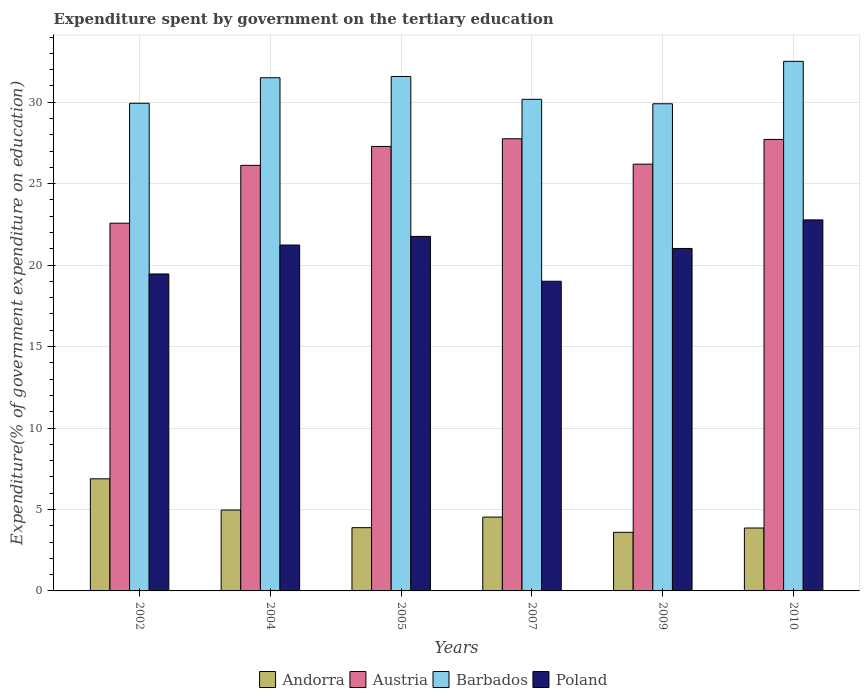How many groups of bars are there?
Your response must be concise. 6. Are the number of bars per tick equal to the number of legend labels?
Ensure brevity in your answer.  Yes. Are the number of bars on each tick of the X-axis equal?
Your response must be concise. Yes. How many bars are there on the 4th tick from the left?
Keep it short and to the point. 4. How many bars are there on the 1st tick from the right?
Offer a terse response. 4. What is the label of the 1st group of bars from the left?
Provide a short and direct response. 2002. What is the expenditure spent by government on the tertiary education in Barbados in 2009?
Give a very brief answer. 29.9. Across all years, what is the maximum expenditure spent by government on the tertiary education in Barbados?
Provide a short and direct response. 32.51. Across all years, what is the minimum expenditure spent by government on the tertiary education in Austria?
Your answer should be very brief. 22.57. What is the total expenditure spent by government on the tertiary education in Austria in the graph?
Your answer should be compact. 157.64. What is the difference between the expenditure spent by government on the tertiary education in Barbados in 2002 and that in 2007?
Ensure brevity in your answer.  -0.24. What is the difference between the expenditure spent by government on the tertiary education in Poland in 2007 and the expenditure spent by government on the tertiary education in Barbados in 2004?
Ensure brevity in your answer.  -12.49. What is the average expenditure spent by government on the tertiary education in Barbados per year?
Provide a succinct answer. 30.93. In the year 2009, what is the difference between the expenditure spent by government on the tertiary education in Andorra and expenditure spent by government on the tertiary education in Barbados?
Offer a very short reply. -26.3. In how many years, is the expenditure spent by government on the tertiary education in Austria greater than 13 %?
Your answer should be compact. 6. What is the ratio of the expenditure spent by government on the tertiary education in Barbados in 2007 to that in 2009?
Offer a very short reply. 1.01. Is the expenditure spent by government on the tertiary education in Barbados in 2002 less than that in 2009?
Ensure brevity in your answer.  No. What is the difference between the highest and the second highest expenditure spent by government on the tertiary education in Austria?
Keep it short and to the point. 0.04. What is the difference between the highest and the lowest expenditure spent by government on the tertiary education in Poland?
Your response must be concise. 3.77. In how many years, is the expenditure spent by government on the tertiary education in Andorra greater than the average expenditure spent by government on the tertiary education in Andorra taken over all years?
Provide a short and direct response. 2. Is the sum of the expenditure spent by government on the tertiary education in Andorra in 2007 and 2010 greater than the maximum expenditure spent by government on the tertiary education in Austria across all years?
Give a very brief answer. No. Is it the case that in every year, the sum of the expenditure spent by government on the tertiary education in Barbados and expenditure spent by government on the tertiary education in Andorra is greater than the sum of expenditure spent by government on the tertiary education in Austria and expenditure spent by government on the tertiary education in Poland?
Your answer should be very brief. No. What does the 4th bar from the right in 2010 represents?
Your answer should be compact. Andorra. Is it the case that in every year, the sum of the expenditure spent by government on the tertiary education in Austria and expenditure spent by government on the tertiary education in Poland is greater than the expenditure spent by government on the tertiary education in Andorra?
Offer a terse response. Yes. How many bars are there?
Provide a succinct answer. 24. Are all the bars in the graph horizontal?
Provide a succinct answer. No. What is the difference between two consecutive major ticks on the Y-axis?
Keep it short and to the point. 5. Are the values on the major ticks of Y-axis written in scientific E-notation?
Provide a short and direct response. No. Does the graph contain any zero values?
Ensure brevity in your answer.  No. Does the graph contain grids?
Your answer should be very brief. Yes. Where does the legend appear in the graph?
Ensure brevity in your answer.  Bottom center. How many legend labels are there?
Provide a succinct answer. 4. What is the title of the graph?
Offer a terse response. Expenditure spent by government on the tertiary education. Does "Mongolia" appear as one of the legend labels in the graph?
Your answer should be compact. No. What is the label or title of the Y-axis?
Offer a very short reply. Expenditure(% of government expenditure on education). What is the Expenditure(% of government expenditure on education) in Andorra in 2002?
Ensure brevity in your answer.  6.88. What is the Expenditure(% of government expenditure on education) of Austria in 2002?
Keep it short and to the point. 22.57. What is the Expenditure(% of government expenditure on education) of Barbados in 2002?
Make the answer very short. 29.93. What is the Expenditure(% of government expenditure on education) in Poland in 2002?
Your answer should be very brief. 19.45. What is the Expenditure(% of government expenditure on education) of Andorra in 2004?
Provide a short and direct response. 4.96. What is the Expenditure(% of government expenditure on education) in Austria in 2004?
Keep it short and to the point. 26.12. What is the Expenditure(% of government expenditure on education) in Barbados in 2004?
Offer a terse response. 31.5. What is the Expenditure(% of government expenditure on education) in Poland in 2004?
Your answer should be compact. 21.23. What is the Expenditure(% of government expenditure on education) in Andorra in 2005?
Your response must be concise. 3.88. What is the Expenditure(% of government expenditure on education) of Austria in 2005?
Your response must be concise. 27.28. What is the Expenditure(% of government expenditure on education) of Barbados in 2005?
Your answer should be compact. 31.58. What is the Expenditure(% of government expenditure on education) of Poland in 2005?
Offer a very short reply. 21.76. What is the Expenditure(% of government expenditure on education) of Andorra in 2007?
Your answer should be compact. 4.53. What is the Expenditure(% of government expenditure on education) of Austria in 2007?
Your response must be concise. 27.75. What is the Expenditure(% of government expenditure on education) in Barbados in 2007?
Your answer should be very brief. 30.18. What is the Expenditure(% of government expenditure on education) in Poland in 2007?
Provide a short and direct response. 19.01. What is the Expenditure(% of government expenditure on education) of Andorra in 2009?
Your answer should be very brief. 3.6. What is the Expenditure(% of government expenditure on education) of Austria in 2009?
Your response must be concise. 26.2. What is the Expenditure(% of government expenditure on education) in Barbados in 2009?
Ensure brevity in your answer.  29.9. What is the Expenditure(% of government expenditure on education) of Poland in 2009?
Your answer should be compact. 21.02. What is the Expenditure(% of government expenditure on education) of Andorra in 2010?
Your response must be concise. 3.86. What is the Expenditure(% of government expenditure on education) of Austria in 2010?
Offer a terse response. 27.71. What is the Expenditure(% of government expenditure on education) in Barbados in 2010?
Offer a very short reply. 32.51. What is the Expenditure(% of government expenditure on education) of Poland in 2010?
Give a very brief answer. 22.77. Across all years, what is the maximum Expenditure(% of government expenditure on education) of Andorra?
Give a very brief answer. 6.88. Across all years, what is the maximum Expenditure(% of government expenditure on education) of Austria?
Your response must be concise. 27.75. Across all years, what is the maximum Expenditure(% of government expenditure on education) in Barbados?
Ensure brevity in your answer.  32.51. Across all years, what is the maximum Expenditure(% of government expenditure on education) of Poland?
Ensure brevity in your answer.  22.77. Across all years, what is the minimum Expenditure(% of government expenditure on education) in Andorra?
Your answer should be very brief. 3.6. Across all years, what is the minimum Expenditure(% of government expenditure on education) in Austria?
Your answer should be very brief. 22.57. Across all years, what is the minimum Expenditure(% of government expenditure on education) in Barbados?
Ensure brevity in your answer.  29.9. Across all years, what is the minimum Expenditure(% of government expenditure on education) in Poland?
Keep it short and to the point. 19.01. What is the total Expenditure(% of government expenditure on education) of Andorra in the graph?
Your answer should be compact. 27.72. What is the total Expenditure(% of government expenditure on education) of Austria in the graph?
Give a very brief answer. 157.64. What is the total Expenditure(% of government expenditure on education) in Barbados in the graph?
Make the answer very short. 185.6. What is the total Expenditure(% of government expenditure on education) of Poland in the graph?
Your answer should be very brief. 125.25. What is the difference between the Expenditure(% of government expenditure on education) of Andorra in 2002 and that in 2004?
Your response must be concise. 1.92. What is the difference between the Expenditure(% of government expenditure on education) of Austria in 2002 and that in 2004?
Make the answer very short. -3.55. What is the difference between the Expenditure(% of government expenditure on education) in Barbados in 2002 and that in 2004?
Your response must be concise. -1.57. What is the difference between the Expenditure(% of government expenditure on education) of Poland in 2002 and that in 2004?
Offer a very short reply. -1.78. What is the difference between the Expenditure(% of government expenditure on education) of Andorra in 2002 and that in 2005?
Make the answer very short. 3. What is the difference between the Expenditure(% of government expenditure on education) of Austria in 2002 and that in 2005?
Provide a short and direct response. -4.71. What is the difference between the Expenditure(% of government expenditure on education) of Barbados in 2002 and that in 2005?
Offer a very short reply. -1.65. What is the difference between the Expenditure(% of government expenditure on education) in Poland in 2002 and that in 2005?
Offer a terse response. -2.31. What is the difference between the Expenditure(% of government expenditure on education) of Andorra in 2002 and that in 2007?
Your answer should be compact. 2.35. What is the difference between the Expenditure(% of government expenditure on education) in Austria in 2002 and that in 2007?
Ensure brevity in your answer.  -5.18. What is the difference between the Expenditure(% of government expenditure on education) of Barbados in 2002 and that in 2007?
Provide a short and direct response. -0.24. What is the difference between the Expenditure(% of government expenditure on education) of Poland in 2002 and that in 2007?
Offer a terse response. 0.45. What is the difference between the Expenditure(% of government expenditure on education) in Andorra in 2002 and that in 2009?
Offer a very short reply. 3.28. What is the difference between the Expenditure(% of government expenditure on education) in Austria in 2002 and that in 2009?
Make the answer very short. -3.62. What is the difference between the Expenditure(% of government expenditure on education) in Barbados in 2002 and that in 2009?
Provide a succinct answer. 0.03. What is the difference between the Expenditure(% of government expenditure on education) in Poland in 2002 and that in 2009?
Your answer should be very brief. -1.57. What is the difference between the Expenditure(% of government expenditure on education) in Andorra in 2002 and that in 2010?
Your answer should be compact. 3.02. What is the difference between the Expenditure(% of government expenditure on education) in Austria in 2002 and that in 2010?
Provide a short and direct response. -5.14. What is the difference between the Expenditure(% of government expenditure on education) in Barbados in 2002 and that in 2010?
Ensure brevity in your answer.  -2.57. What is the difference between the Expenditure(% of government expenditure on education) in Poland in 2002 and that in 2010?
Ensure brevity in your answer.  -3.32. What is the difference between the Expenditure(% of government expenditure on education) of Andorra in 2004 and that in 2005?
Provide a short and direct response. 1.08. What is the difference between the Expenditure(% of government expenditure on education) of Austria in 2004 and that in 2005?
Your answer should be very brief. -1.16. What is the difference between the Expenditure(% of government expenditure on education) in Barbados in 2004 and that in 2005?
Make the answer very short. -0.08. What is the difference between the Expenditure(% of government expenditure on education) in Poland in 2004 and that in 2005?
Ensure brevity in your answer.  -0.53. What is the difference between the Expenditure(% of government expenditure on education) of Andorra in 2004 and that in 2007?
Your response must be concise. 0.43. What is the difference between the Expenditure(% of government expenditure on education) of Austria in 2004 and that in 2007?
Give a very brief answer. -1.63. What is the difference between the Expenditure(% of government expenditure on education) of Barbados in 2004 and that in 2007?
Ensure brevity in your answer.  1.32. What is the difference between the Expenditure(% of government expenditure on education) of Poland in 2004 and that in 2007?
Your response must be concise. 2.22. What is the difference between the Expenditure(% of government expenditure on education) of Andorra in 2004 and that in 2009?
Make the answer very short. 1.37. What is the difference between the Expenditure(% of government expenditure on education) of Austria in 2004 and that in 2009?
Provide a succinct answer. -0.07. What is the difference between the Expenditure(% of government expenditure on education) in Barbados in 2004 and that in 2009?
Keep it short and to the point. 1.6. What is the difference between the Expenditure(% of government expenditure on education) of Poland in 2004 and that in 2009?
Your response must be concise. 0.21. What is the difference between the Expenditure(% of government expenditure on education) in Andorra in 2004 and that in 2010?
Make the answer very short. 1.1. What is the difference between the Expenditure(% of government expenditure on education) of Austria in 2004 and that in 2010?
Your answer should be very brief. -1.59. What is the difference between the Expenditure(% of government expenditure on education) in Barbados in 2004 and that in 2010?
Make the answer very short. -1.01. What is the difference between the Expenditure(% of government expenditure on education) in Poland in 2004 and that in 2010?
Your response must be concise. -1.54. What is the difference between the Expenditure(% of government expenditure on education) of Andorra in 2005 and that in 2007?
Provide a succinct answer. -0.65. What is the difference between the Expenditure(% of government expenditure on education) in Austria in 2005 and that in 2007?
Your response must be concise. -0.47. What is the difference between the Expenditure(% of government expenditure on education) of Barbados in 2005 and that in 2007?
Your answer should be very brief. 1.4. What is the difference between the Expenditure(% of government expenditure on education) of Poland in 2005 and that in 2007?
Your answer should be very brief. 2.75. What is the difference between the Expenditure(% of government expenditure on education) of Andorra in 2005 and that in 2009?
Give a very brief answer. 0.28. What is the difference between the Expenditure(% of government expenditure on education) in Austria in 2005 and that in 2009?
Provide a succinct answer. 1.09. What is the difference between the Expenditure(% of government expenditure on education) of Barbados in 2005 and that in 2009?
Offer a terse response. 1.67. What is the difference between the Expenditure(% of government expenditure on education) in Poland in 2005 and that in 2009?
Your answer should be very brief. 0.74. What is the difference between the Expenditure(% of government expenditure on education) in Andorra in 2005 and that in 2010?
Offer a terse response. 0.02. What is the difference between the Expenditure(% of government expenditure on education) of Austria in 2005 and that in 2010?
Keep it short and to the point. -0.43. What is the difference between the Expenditure(% of government expenditure on education) in Barbados in 2005 and that in 2010?
Keep it short and to the point. -0.93. What is the difference between the Expenditure(% of government expenditure on education) in Poland in 2005 and that in 2010?
Your response must be concise. -1.01. What is the difference between the Expenditure(% of government expenditure on education) in Andorra in 2007 and that in 2009?
Keep it short and to the point. 0.93. What is the difference between the Expenditure(% of government expenditure on education) in Austria in 2007 and that in 2009?
Provide a succinct answer. 1.56. What is the difference between the Expenditure(% of government expenditure on education) of Barbados in 2007 and that in 2009?
Your response must be concise. 0.27. What is the difference between the Expenditure(% of government expenditure on education) in Poland in 2007 and that in 2009?
Give a very brief answer. -2.01. What is the difference between the Expenditure(% of government expenditure on education) of Andorra in 2007 and that in 2010?
Provide a short and direct response. 0.67. What is the difference between the Expenditure(% of government expenditure on education) of Austria in 2007 and that in 2010?
Make the answer very short. 0.04. What is the difference between the Expenditure(% of government expenditure on education) of Barbados in 2007 and that in 2010?
Offer a terse response. -2.33. What is the difference between the Expenditure(% of government expenditure on education) of Poland in 2007 and that in 2010?
Offer a terse response. -3.77. What is the difference between the Expenditure(% of government expenditure on education) in Andorra in 2009 and that in 2010?
Provide a succinct answer. -0.26. What is the difference between the Expenditure(% of government expenditure on education) in Austria in 2009 and that in 2010?
Your answer should be compact. -1.52. What is the difference between the Expenditure(% of government expenditure on education) in Barbados in 2009 and that in 2010?
Make the answer very short. -2.6. What is the difference between the Expenditure(% of government expenditure on education) in Poland in 2009 and that in 2010?
Ensure brevity in your answer.  -1.75. What is the difference between the Expenditure(% of government expenditure on education) in Andorra in 2002 and the Expenditure(% of government expenditure on education) in Austria in 2004?
Your answer should be very brief. -19.24. What is the difference between the Expenditure(% of government expenditure on education) of Andorra in 2002 and the Expenditure(% of government expenditure on education) of Barbados in 2004?
Provide a short and direct response. -24.62. What is the difference between the Expenditure(% of government expenditure on education) of Andorra in 2002 and the Expenditure(% of government expenditure on education) of Poland in 2004?
Offer a terse response. -14.35. What is the difference between the Expenditure(% of government expenditure on education) of Austria in 2002 and the Expenditure(% of government expenditure on education) of Barbados in 2004?
Make the answer very short. -8.93. What is the difference between the Expenditure(% of government expenditure on education) in Austria in 2002 and the Expenditure(% of government expenditure on education) in Poland in 2004?
Offer a terse response. 1.34. What is the difference between the Expenditure(% of government expenditure on education) of Barbados in 2002 and the Expenditure(% of government expenditure on education) of Poland in 2004?
Offer a terse response. 8.7. What is the difference between the Expenditure(% of government expenditure on education) of Andorra in 2002 and the Expenditure(% of government expenditure on education) of Austria in 2005?
Your response must be concise. -20.4. What is the difference between the Expenditure(% of government expenditure on education) of Andorra in 2002 and the Expenditure(% of government expenditure on education) of Barbados in 2005?
Offer a terse response. -24.7. What is the difference between the Expenditure(% of government expenditure on education) in Andorra in 2002 and the Expenditure(% of government expenditure on education) in Poland in 2005?
Give a very brief answer. -14.88. What is the difference between the Expenditure(% of government expenditure on education) in Austria in 2002 and the Expenditure(% of government expenditure on education) in Barbados in 2005?
Offer a terse response. -9.01. What is the difference between the Expenditure(% of government expenditure on education) in Austria in 2002 and the Expenditure(% of government expenditure on education) in Poland in 2005?
Offer a terse response. 0.81. What is the difference between the Expenditure(% of government expenditure on education) in Barbados in 2002 and the Expenditure(% of government expenditure on education) in Poland in 2005?
Offer a very short reply. 8.17. What is the difference between the Expenditure(% of government expenditure on education) of Andorra in 2002 and the Expenditure(% of government expenditure on education) of Austria in 2007?
Give a very brief answer. -20.87. What is the difference between the Expenditure(% of government expenditure on education) in Andorra in 2002 and the Expenditure(% of government expenditure on education) in Barbados in 2007?
Provide a succinct answer. -23.29. What is the difference between the Expenditure(% of government expenditure on education) in Andorra in 2002 and the Expenditure(% of government expenditure on education) in Poland in 2007?
Make the answer very short. -12.13. What is the difference between the Expenditure(% of government expenditure on education) of Austria in 2002 and the Expenditure(% of government expenditure on education) of Barbados in 2007?
Keep it short and to the point. -7.61. What is the difference between the Expenditure(% of government expenditure on education) in Austria in 2002 and the Expenditure(% of government expenditure on education) in Poland in 2007?
Provide a succinct answer. 3.56. What is the difference between the Expenditure(% of government expenditure on education) of Barbados in 2002 and the Expenditure(% of government expenditure on education) of Poland in 2007?
Give a very brief answer. 10.92. What is the difference between the Expenditure(% of government expenditure on education) of Andorra in 2002 and the Expenditure(% of government expenditure on education) of Austria in 2009?
Your answer should be very brief. -19.31. What is the difference between the Expenditure(% of government expenditure on education) of Andorra in 2002 and the Expenditure(% of government expenditure on education) of Barbados in 2009?
Your answer should be very brief. -23.02. What is the difference between the Expenditure(% of government expenditure on education) of Andorra in 2002 and the Expenditure(% of government expenditure on education) of Poland in 2009?
Offer a terse response. -14.14. What is the difference between the Expenditure(% of government expenditure on education) in Austria in 2002 and the Expenditure(% of government expenditure on education) in Barbados in 2009?
Provide a short and direct response. -7.33. What is the difference between the Expenditure(% of government expenditure on education) in Austria in 2002 and the Expenditure(% of government expenditure on education) in Poland in 2009?
Provide a short and direct response. 1.55. What is the difference between the Expenditure(% of government expenditure on education) in Barbados in 2002 and the Expenditure(% of government expenditure on education) in Poland in 2009?
Ensure brevity in your answer.  8.91. What is the difference between the Expenditure(% of government expenditure on education) in Andorra in 2002 and the Expenditure(% of government expenditure on education) in Austria in 2010?
Keep it short and to the point. -20.83. What is the difference between the Expenditure(% of government expenditure on education) of Andorra in 2002 and the Expenditure(% of government expenditure on education) of Barbados in 2010?
Keep it short and to the point. -25.62. What is the difference between the Expenditure(% of government expenditure on education) in Andorra in 2002 and the Expenditure(% of government expenditure on education) in Poland in 2010?
Provide a succinct answer. -15.89. What is the difference between the Expenditure(% of government expenditure on education) in Austria in 2002 and the Expenditure(% of government expenditure on education) in Barbados in 2010?
Provide a short and direct response. -9.93. What is the difference between the Expenditure(% of government expenditure on education) in Austria in 2002 and the Expenditure(% of government expenditure on education) in Poland in 2010?
Make the answer very short. -0.2. What is the difference between the Expenditure(% of government expenditure on education) of Barbados in 2002 and the Expenditure(% of government expenditure on education) of Poland in 2010?
Your answer should be very brief. 7.16. What is the difference between the Expenditure(% of government expenditure on education) of Andorra in 2004 and the Expenditure(% of government expenditure on education) of Austria in 2005?
Offer a very short reply. -22.32. What is the difference between the Expenditure(% of government expenditure on education) of Andorra in 2004 and the Expenditure(% of government expenditure on education) of Barbados in 2005?
Your answer should be very brief. -26.61. What is the difference between the Expenditure(% of government expenditure on education) of Andorra in 2004 and the Expenditure(% of government expenditure on education) of Poland in 2005?
Give a very brief answer. -16.8. What is the difference between the Expenditure(% of government expenditure on education) of Austria in 2004 and the Expenditure(% of government expenditure on education) of Barbados in 2005?
Your answer should be compact. -5.46. What is the difference between the Expenditure(% of government expenditure on education) of Austria in 2004 and the Expenditure(% of government expenditure on education) of Poland in 2005?
Offer a very short reply. 4.36. What is the difference between the Expenditure(% of government expenditure on education) in Barbados in 2004 and the Expenditure(% of government expenditure on education) in Poland in 2005?
Your answer should be compact. 9.74. What is the difference between the Expenditure(% of government expenditure on education) of Andorra in 2004 and the Expenditure(% of government expenditure on education) of Austria in 2007?
Offer a very short reply. -22.79. What is the difference between the Expenditure(% of government expenditure on education) of Andorra in 2004 and the Expenditure(% of government expenditure on education) of Barbados in 2007?
Ensure brevity in your answer.  -25.21. What is the difference between the Expenditure(% of government expenditure on education) of Andorra in 2004 and the Expenditure(% of government expenditure on education) of Poland in 2007?
Ensure brevity in your answer.  -14.04. What is the difference between the Expenditure(% of government expenditure on education) in Austria in 2004 and the Expenditure(% of government expenditure on education) in Barbados in 2007?
Give a very brief answer. -4.06. What is the difference between the Expenditure(% of government expenditure on education) in Austria in 2004 and the Expenditure(% of government expenditure on education) in Poland in 2007?
Ensure brevity in your answer.  7.11. What is the difference between the Expenditure(% of government expenditure on education) in Barbados in 2004 and the Expenditure(% of government expenditure on education) in Poland in 2007?
Provide a short and direct response. 12.49. What is the difference between the Expenditure(% of government expenditure on education) in Andorra in 2004 and the Expenditure(% of government expenditure on education) in Austria in 2009?
Offer a terse response. -21.23. What is the difference between the Expenditure(% of government expenditure on education) of Andorra in 2004 and the Expenditure(% of government expenditure on education) of Barbados in 2009?
Your response must be concise. -24.94. What is the difference between the Expenditure(% of government expenditure on education) in Andorra in 2004 and the Expenditure(% of government expenditure on education) in Poland in 2009?
Provide a short and direct response. -16.06. What is the difference between the Expenditure(% of government expenditure on education) of Austria in 2004 and the Expenditure(% of government expenditure on education) of Barbados in 2009?
Provide a short and direct response. -3.78. What is the difference between the Expenditure(% of government expenditure on education) of Austria in 2004 and the Expenditure(% of government expenditure on education) of Poland in 2009?
Give a very brief answer. 5.1. What is the difference between the Expenditure(% of government expenditure on education) of Barbados in 2004 and the Expenditure(% of government expenditure on education) of Poland in 2009?
Offer a terse response. 10.48. What is the difference between the Expenditure(% of government expenditure on education) in Andorra in 2004 and the Expenditure(% of government expenditure on education) in Austria in 2010?
Make the answer very short. -22.75. What is the difference between the Expenditure(% of government expenditure on education) of Andorra in 2004 and the Expenditure(% of government expenditure on education) of Barbados in 2010?
Provide a succinct answer. -27.54. What is the difference between the Expenditure(% of government expenditure on education) in Andorra in 2004 and the Expenditure(% of government expenditure on education) in Poland in 2010?
Offer a very short reply. -17.81. What is the difference between the Expenditure(% of government expenditure on education) of Austria in 2004 and the Expenditure(% of government expenditure on education) of Barbados in 2010?
Your response must be concise. -6.38. What is the difference between the Expenditure(% of government expenditure on education) in Austria in 2004 and the Expenditure(% of government expenditure on education) in Poland in 2010?
Give a very brief answer. 3.35. What is the difference between the Expenditure(% of government expenditure on education) in Barbados in 2004 and the Expenditure(% of government expenditure on education) in Poland in 2010?
Provide a short and direct response. 8.73. What is the difference between the Expenditure(% of government expenditure on education) of Andorra in 2005 and the Expenditure(% of government expenditure on education) of Austria in 2007?
Provide a succinct answer. -23.87. What is the difference between the Expenditure(% of government expenditure on education) of Andorra in 2005 and the Expenditure(% of government expenditure on education) of Barbados in 2007?
Give a very brief answer. -26.29. What is the difference between the Expenditure(% of government expenditure on education) of Andorra in 2005 and the Expenditure(% of government expenditure on education) of Poland in 2007?
Keep it short and to the point. -15.13. What is the difference between the Expenditure(% of government expenditure on education) of Austria in 2005 and the Expenditure(% of government expenditure on education) of Barbados in 2007?
Offer a very short reply. -2.89. What is the difference between the Expenditure(% of government expenditure on education) in Austria in 2005 and the Expenditure(% of government expenditure on education) in Poland in 2007?
Your answer should be very brief. 8.27. What is the difference between the Expenditure(% of government expenditure on education) in Barbados in 2005 and the Expenditure(% of government expenditure on education) in Poland in 2007?
Your answer should be compact. 12.57. What is the difference between the Expenditure(% of government expenditure on education) of Andorra in 2005 and the Expenditure(% of government expenditure on education) of Austria in 2009?
Ensure brevity in your answer.  -22.31. What is the difference between the Expenditure(% of government expenditure on education) of Andorra in 2005 and the Expenditure(% of government expenditure on education) of Barbados in 2009?
Provide a succinct answer. -26.02. What is the difference between the Expenditure(% of government expenditure on education) of Andorra in 2005 and the Expenditure(% of government expenditure on education) of Poland in 2009?
Provide a short and direct response. -17.14. What is the difference between the Expenditure(% of government expenditure on education) of Austria in 2005 and the Expenditure(% of government expenditure on education) of Barbados in 2009?
Make the answer very short. -2.62. What is the difference between the Expenditure(% of government expenditure on education) in Austria in 2005 and the Expenditure(% of government expenditure on education) in Poland in 2009?
Your response must be concise. 6.26. What is the difference between the Expenditure(% of government expenditure on education) of Barbados in 2005 and the Expenditure(% of government expenditure on education) of Poland in 2009?
Give a very brief answer. 10.56. What is the difference between the Expenditure(% of government expenditure on education) in Andorra in 2005 and the Expenditure(% of government expenditure on education) in Austria in 2010?
Provide a short and direct response. -23.83. What is the difference between the Expenditure(% of government expenditure on education) of Andorra in 2005 and the Expenditure(% of government expenditure on education) of Barbados in 2010?
Provide a succinct answer. -28.62. What is the difference between the Expenditure(% of government expenditure on education) in Andorra in 2005 and the Expenditure(% of government expenditure on education) in Poland in 2010?
Your answer should be very brief. -18.89. What is the difference between the Expenditure(% of government expenditure on education) in Austria in 2005 and the Expenditure(% of government expenditure on education) in Barbados in 2010?
Make the answer very short. -5.22. What is the difference between the Expenditure(% of government expenditure on education) of Austria in 2005 and the Expenditure(% of government expenditure on education) of Poland in 2010?
Your answer should be compact. 4.51. What is the difference between the Expenditure(% of government expenditure on education) of Barbados in 2005 and the Expenditure(% of government expenditure on education) of Poland in 2010?
Provide a succinct answer. 8.8. What is the difference between the Expenditure(% of government expenditure on education) in Andorra in 2007 and the Expenditure(% of government expenditure on education) in Austria in 2009?
Keep it short and to the point. -21.66. What is the difference between the Expenditure(% of government expenditure on education) in Andorra in 2007 and the Expenditure(% of government expenditure on education) in Barbados in 2009?
Provide a short and direct response. -25.37. What is the difference between the Expenditure(% of government expenditure on education) in Andorra in 2007 and the Expenditure(% of government expenditure on education) in Poland in 2009?
Give a very brief answer. -16.49. What is the difference between the Expenditure(% of government expenditure on education) of Austria in 2007 and the Expenditure(% of government expenditure on education) of Barbados in 2009?
Provide a short and direct response. -2.15. What is the difference between the Expenditure(% of government expenditure on education) in Austria in 2007 and the Expenditure(% of government expenditure on education) in Poland in 2009?
Keep it short and to the point. 6.73. What is the difference between the Expenditure(% of government expenditure on education) of Barbados in 2007 and the Expenditure(% of government expenditure on education) of Poland in 2009?
Provide a succinct answer. 9.16. What is the difference between the Expenditure(% of government expenditure on education) in Andorra in 2007 and the Expenditure(% of government expenditure on education) in Austria in 2010?
Provide a short and direct response. -23.18. What is the difference between the Expenditure(% of government expenditure on education) in Andorra in 2007 and the Expenditure(% of government expenditure on education) in Barbados in 2010?
Give a very brief answer. -27.97. What is the difference between the Expenditure(% of government expenditure on education) of Andorra in 2007 and the Expenditure(% of government expenditure on education) of Poland in 2010?
Your answer should be compact. -18.24. What is the difference between the Expenditure(% of government expenditure on education) of Austria in 2007 and the Expenditure(% of government expenditure on education) of Barbados in 2010?
Your response must be concise. -4.75. What is the difference between the Expenditure(% of government expenditure on education) of Austria in 2007 and the Expenditure(% of government expenditure on education) of Poland in 2010?
Your answer should be very brief. 4.98. What is the difference between the Expenditure(% of government expenditure on education) in Barbados in 2007 and the Expenditure(% of government expenditure on education) in Poland in 2010?
Provide a succinct answer. 7.4. What is the difference between the Expenditure(% of government expenditure on education) of Andorra in 2009 and the Expenditure(% of government expenditure on education) of Austria in 2010?
Your response must be concise. -24.12. What is the difference between the Expenditure(% of government expenditure on education) of Andorra in 2009 and the Expenditure(% of government expenditure on education) of Barbados in 2010?
Your answer should be compact. -28.91. What is the difference between the Expenditure(% of government expenditure on education) of Andorra in 2009 and the Expenditure(% of government expenditure on education) of Poland in 2010?
Ensure brevity in your answer.  -19.18. What is the difference between the Expenditure(% of government expenditure on education) of Austria in 2009 and the Expenditure(% of government expenditure on education) of Barbados in 2010?
Offer a very short reply. -6.31. What is the difference between the Expenditure(% of government expenditure on education) of Austria in 2009 and the Expenditure(% of government expenditure on education) of Poland in 2010?
Provide a short and direct response. 3.42. What is the difference between the Expenditure(% of government expenditure on education) of Barbados in 2009 and the Expenditure(% of government expenditure on education) of Poland in 2010?
Keep it short and to the point. 7.13. What is the average Expenditure(% of government expenditure on education) in Andorra per year?
Offer a terse response. 4.62. What is the average Expenditure(% of government expenditure on education) of Austria per year?
Give a very brief answer. 26.27. What is the average Expenditure(% of government expenditure on education) in Barbados per year?
Offer a very short reply. 30.93. What is the average Expenditure(% of government expenditure on education) in Poland per year?
Give a very brief answer. 20.88. In the year 2002, what is the difference between the Expenditure(% of government expenditure on education) in Andorra and Expenditure(% of government expenditure on education) in Austria?
Give a very brief answer. -15.69. In the year 2002, what is the difference between the Expenditure(% of government expenditure on education) of Andorra and Expenditure(% of government expenditure on education) of Barbados?
Your response must be concise. -23.05. In the year 2002, what is the difference between the Expenditure(% of government expenditure on education) of Andorra and Expenditure(% of government expenditure on education) of Poland?
Make the answer very short. -12.57. In the year 2002, what is the difference between the Expenditure(% of government expenditure on education) of Austria and Expenditure(% of government expenditure on education) of Barbados?
Provide a short and direct response. -7.36. In the year 2002, what is the difference between the Expenditure(% of government expenditure on education) of Austria and Expenditure(% of government expenditure on education) of Poland?
Give a very brief answer. 3.12. In the year 2002, what is the difference between the Expenditure(% of government expenditure on education) of Barbados and Expenditure(% of government expenditure on education) of Poland?
Your answer should be compact. 10.48. In the year 2004, what is the difference between the Expenditure(% of government expenditure on education) in Andorra and Expenditure(% of government expenditure on education) in Austria?
Give a very brief answer. -21.16. In the year 2004, what is the difference between the Expenditure(% of government expenditure on education) in Andorra and Expenditure(% of government expenditure on education) in Barbados?
Ensure brevity in your answer.  -26.54. In the year 2004, what is the difference between the Expenditure(% of government expenditure on education) in Andorra and Expenditure(% of government expenditure on education) in Poland?
Keep it short and to the point. -16.27. In the year 2004, what is the difference between the Expenditure(% of government expenditure on education) in Austria and Expenditure(% of government expenditure on education) in Barbados?
Give a very brief answer. -5.38. In the year 2004, what is the difference between the Expenditure(% of government expenditure on education) in Austria and Expenditure(% of government expenditure on education) in Poland?
Provide a succinct answer. 4.89. In the year 2004, what is the difference between the Expenditure(% of government expenditure on education) in Barbados and Expenditure(% of government expenditure on education) in Poland?
Offer a very short reply. 10.27. In the year 2005, what is the difference between the Expenditure(% of government expenditure on education) of Andorra and Expenditure(% of government expenditure on education) of Austria?
Give a very brief answer. -23.4. In the year 2005, what is the difference between the Expenditure(% of government expenditure on education) in Andorra and Expenditure(% of government expenditure on education) in Barbados?
Your answer should be compact. -27.7. In the year 2005, what is the difference between the Expenditure(% of government expenditure on education) in Andorra and Expenditure(% of government expenditure on education) in Poland?
Ensure brevity in your answer.  -17.88. In the year 2005, what is the difference between the Expenditure(% of government expenditure on education) of Austria and Expenditure(% of government expenditure on education) of Barbados?
Your answer should be very brief. -4.29. In the year 2005, what is the difference between the Expenditure(% of government expenditure on education) of Austria and Expenditure(% of government expenditure on education) of Poland?
Provide a succinct answer. 5.52. In the year 2005, what is the difference between the Expenditure(% of government expenditure on education) of Barbados and Expenditure(% of government expenditure on education) of Poland?
Give a very brief answer. 9.82. In the year 2007, what is the difference between the Expenditure(% of government expenditure on education) in Andorra and Expenditure(% of government expenditure on education) in Austria?
Offer a very short reply. -23.22. In the year 2007, what is the difference between the Expenditure(% of government expenditure on education) in Andorra and Expenditure(% of government expenditure on education) in Barbados?
Ensure brevity in your answer.  -25.64. In the year 2007, what is the difference between the Expenditure(% of government expenditure on education) of Andorra and Expenditure(% of government expenditure on education) of Poland?
Give a very brief answer. -14.48. In the year 2007, what is the difference between the Expenditure(% of government expenditure on education) of Austria and Expenditure(% of government expenditure on education) of Barbados?
Give a very brief answer. -2.42. In the year 2007, what is the difference between the Expenditure(% of government expenditure on education) of Austria and Expenditure(% of government expenditure on education) of Poland?
Offer a terse response. 8.74. In the year 2007, what is the difference between the Expenditure(% of government expenditure on education) in Barbados and Expenditure(% of government expenditure on education) in Poland?
Your answer should be compact. 11.17. In the year 2009, what is the difference between the Expenditure(% of government expenditure on education) of Andorra and Expenditure(% of government expenditure on education) of Austria?
Offer a very short reply. -22.6. In the year 2009, what is the difference between the Expenditure(% of government expenditure on education) of Andorra and Expenditure(% of government expenditure on education) of Barbados?
Offer a very short reply. -26.3. In the year 2009, what is the difference between the Expenditure(% of government expenditure on education) of Andorra and Expenditure(% of government expenditure on education) of Poland?
Provide a succinct answer. -17.42. In the year 2009, what is the difference between the Expenditure(% of government expenditure on education) in Austria and Expenditure(% of government expenditure on education) in Barbados?
Provide a succinct answer. -3.71. In the year 2009, what is the difference between the Expenditure(% of government expenditure on education) in Austria and Expenditure(% of government expenditure on education) in Poland?
Provide a succinct answer. 5.17. In the year 2009, what is the difference between the Expenditure(% of government expenditure on education) in Barbados and Expenditure(% of government expenditure on education) in Poland?
Offer a terse response. 8.88. In the year 2010, what is the difference between the Expenditure(% of government expenditure on education) in Andorra and Expenditure(% of government expenditure on education) in Austria?
Give a very brief answer. -23.85. In the year 2010, what is the difference between the Expenditure(% of government expenditure on education) in Andorra and Expenditure(% of government expenditure on education) in Barbados?
Offer a terse response. -28.64. In the year 2010, what is the difference between the Expenditure(% of government expenditure on education) of Andorra and Expenditure(% of government expenditure on education) of Poland?
Give a very brief answer. -18.91. In the year 2010, what is the difference between the Expenditure(% of government expenditure on education) of Austria and Expenditure(% of government expenditure on education) of Barbados?
Keep it short and to the point. -4.79. In the year 2010, what is the difference between the Expenditure(% of government expenditure on education) in Austria and Expenditure(% of government expenditure on education) in Poland?
Make the answer very short. 4.94. In the year 2010, what is the difference between the Expenditure(% of government expenditure on education) of Barbados and Expenditure(% of government expenditure on education) of Poland?
Offer a terse response. 9.73. What is the ratio of the Expenditure(% of government expenditure on education) in Andorra in 2002 to that in 2004?
Offer a terse response. 1.39. What is the ratio of the Expenditure(% of government expenditure on education) in Austria in 2002 to that in 2004?
Your response must be concise. 0.86. What is the ratio of the Expenditure(% of government expenditure on education) in Barbados in 2002 to that in 2004?
Keep it short and to the point. 0.95. What is the ratio of the Expenditure(% of government expenditure on education) in Poland in 2002 to that in 2004?
Ensure brevity in your answer.  0.92. What is the ratio of the Expenditure(% of government expenditure on education) in Andorra in 2002 to that in 2005?
Ensure brevity in your answer.  1.77. What is the ratio of the Expenditure(% of government expenditure on education) of Austria in 2002 to that in 2005?
Give a very brief answer. 0.83. What is the ratio of the Expenditure(% of government expenditure on education) of Barbados in 2002 to that in 2005?
Give a very brief answer. 0.95. What is the ratio of the Expenditure(% of government expenditure on education) of Poland in 2002 to that in 2005?
Offer a very short reply. 0.89. What is the ratio of the Expenditure(% of government expenditure on education) of Andorra in 2002 to that in 2007?
Give a very brief answer. 1.52. What is the ratio of the Expenditure(% of government expenditure on education) in Austria in 2002 to that in 2007?
Give a very brief answer. 0.81. What is the ratio of the Expenditure(% of government expenditure on education) in Barbados in 2002 to that in 2007?
Your response must be concise. 0.99. What is the ratio of the Expenditure(% of government expenditure on education) of Poland in 2002 to that in 2007?
Keep it short and to the point. 1.02. What is the ratio of the Expenditure(% of government expenditure on education) in Andorra in 2002 to that in 2009?
Keep it short and to the point. 1.91. What is the ratio of the Expenditure(% of government expenditure on education) of Austria in 2002 to that in 2009?
Provide a succinct answer. 0.86. What is the ratio of the Expenditure(% of government expenditure on education) in Poland in 2002 to that in 2009?
Provide a short and direct response. 0.93. What is the ratio of the Expenditure(% of government expenditure on education) of Andorra in 2002 to that in 2010?
Your answer should be compact. 1.78. What is the ratio of the Expenditure(% of government expenditure on education) of Austria in 2002 to that in 2010?
Provide a short and direct response. 0.81. What is the ratio of the Expenditure(% of government expenditure on education) of Barbados in 2002 to that in 2010?
Offer a very short reply. 0.92. What is the ratio of the Expenditure(% of government expenditure on education) of Poland in 2002 to that in 2010?
Offer a terse response. 0.85. What is the ratio of the Expenditure(% of government expenditure on education) of Andorra in 2004 to that in 2005?
Your answer should be very brief. 1.28. What is the ratio of the Expenditure(% of government expenditure on education) in Austria in 2004 to that in 2005?
Provide a short and direct response. 0.96. What is the ratio of the Expenditure(% of government expenditure on education) of Barbados in 2004 to that in 2005?
Offer a terse response. 1. What is the ratio of the Expenditure(% of government expenditure on education) in Poland in 2004 to that in 2005?
Ensure brevity in your answer.  0.98. What is the ratio of the Expenditure(% of government expenditure on education) of Andorra in 2004 to that in 2007?
Offer a terse response. 1.1. What is the ratio of the Expenditure(% of government expenditure on education) of Austria in 2004 to that in 2007?
Your answer should be compact. 0.94. What is the ratio of the Expenditure(% of government expenditure on education) of Barbados in 2004 to that in 2007?
Offer a terse response. 1.04. What is the ratio of the Expenditure(% of government expenditure on education) of Poland in 2004 to that in 2007?
Your answer should be compact. 1.12. What is the ratio of the Expenditure(% of government expenditure on education) of Andorra in 2004 to that in 2009?
Keep it short and to the point. 1.38. What is the ratio of the Expenditure(% of government expenditure on education) in Austria in 2004 to that in 2009?
Offer a terse response. 1. What is the ratio of the Expenditure(% of government expenditure on education) of Barbados in 2004 to that in 2009?
Provide a succinct answer. 1.05. What is the ratio of the Expenditure(% of government expenditure on education) in Austria in 2004 to that in 2010?
Provide a succinct answer. 0.94. What is the ratio of the Expenditure(% of government expenditure on education) in Barbados in 2004 to that in 2010?
Ensure brevity in your answer.  0.97. What is the ratio of the Expenditure(% of government expenditure on education) of Poland in 2004 to that in 2010?
Provide a succinct answer. 0.93. What is the ratio of the Expenditure(% of government expenditure on education) in Andorra in 2005 to that in 2007?
Offer a very short reply. 0.86. What is the ratio of the Expenditure(% of government expenditure on education) of Barbados in 2005 to that in 2007?
Ensure brevity in your answer.  1.05. What is the ratio of the Expenditure(% of government expenditure on education) of Poland in 2005 to that in 2007?
Your answer should be very brief. 1.14. What is the ratio of the Expenditure(% of government expenditure on education) in Andorra in 2005 to that in 2009?
Make the answer very short. 1.08. What is the ratio of the Expenditure(% of government expenditure on education) in Austria in 2005 to that in 2009?
Keep it short and to the point. 1.04. What is the ratio of the Expenditure(% of government expenditure on education) of Barbados in 2005 to that in 2009?
Keep it short and to the point. 1.06. What is the ratio of the Expenditure(% of government expenditure on education) of Poland in 2005 to that in 2009?
Provide a succinct answer. 1.04. What is the ratio of the Expenditure(% of government expenditure on education) in Austria in 2005 to that in 2010?
Ensure brevity in your answer.  0.98. What is the ratio of the Expenditure(% of government expenditure on education) of Barbados in 2005 to that in 2010?
Your response must be concise. 0.97. What is the ratio of the Expenditure(% of government expenditure on education) in Poland in 2005 to that in 2010?
Provide a succinct answer. 0.96. What is the ratio of the Expenditure(% of government expenditure on education) in Andorra in 2007 to that in 2009?
Provide a succinct answer. 1.26. What is the ratio of the Expenditure(% of government expenditure on education) in Austria in 2007 to that in 2009?
Offer a terse response. 1.06. What is the ratio of the Expenditure(% of government expenditure on education) of Barbados in 2007 to that in 2009?
Make the answer very short. 1.01. What is the ratio of the Expenditure(% of government expenditure on education) of Poland in 2007 to that in 2009?
Ensure brevity in your answer.  0.9. What is the ratio of the Expenditure(% of government expenditure on education) in Andorra in 2007 to that in 2010?
Your answer should be compact. 1.17. What is the ratio of the Expenditure(% of government expenditure on education) in Austria in 2007 to that in 2010?
Give a very brief answer. 1. What is the ratio of the Expenditure(% of government expenditure on education) in Barbados in 2007 to that in 2010?
Offer a terse response. 0.93. What is the ratio of the Expenditure(% of government expenditure on education) of Poland in 2007 to that in 2010?
Offer a very short reply. 0.83. What is the ratio of the Expenditure(% of government expenditure on education) in Andorra in 2009 to that in 2010?
Your answer should be compact. 0.93. What is the ratio of the Expenditure(% of government expenditure on education) in Austria in 2009 to that in 2010?
Give a very brief answer. 0.95. What is the ratio of the Expenditure(% of government expenditure on education) in Barbados in 2009 to that in 2010?
Provide a short and direct response. 0.92. What is the ratio of the Expenditure(% of government expenditure on education) of Poland in 2009 to that in 2010?
Give a very brief answer. 0.92. What is the difference between the highest and the second highest Expenditure(% of government expenditure on education) in Andorra?
Your answer should be compact. 1.92. What is the difference between the highest and the second highest Expenditure(% of government expenditure on education) of Austria?
Your answer should be compact. 0.04. What is the difference between the highest and the second highest Expenditure(% of government expenditure on education) in Barbados?
Keep it short and to the point. 0.93. What is the difference between the highest and the second highest Expenditure(% of government expenditure on education) in Poland?
Ensure brevity in your answer.  1.01. What is the difference between the highest and the lowest Expenditure(% of government expenditure on education) of Andorra?
Provide a succinct answer. 3.28. What is the difference between the highest and the lowest Expenditure(% of government expenditure on education) of Austria?
Provide a succinct answer. 5.18. What is the difference between the highest and the lowest Expenditure(% of government expenditure on education) in Barbados?
Your answer should be very brief. 2.6. What is the difference between the highest and the lowest Expenditure(% of government expenditure on education) of Poland?
Provide a short and direct response. 3.77. 